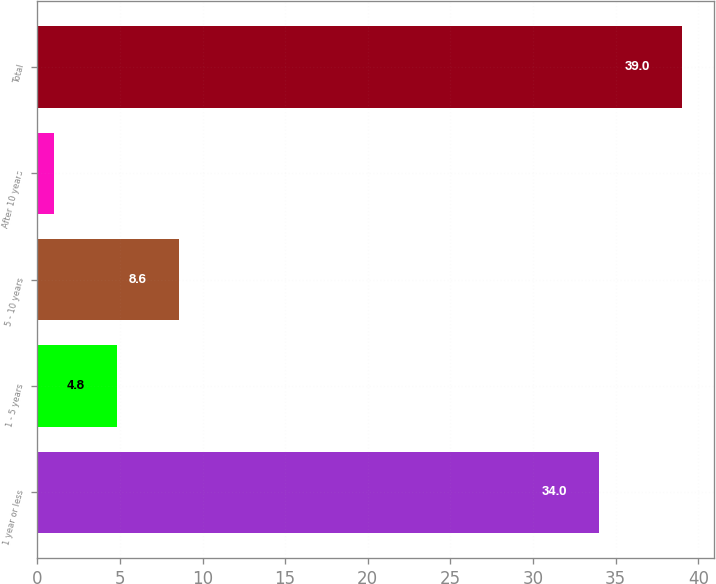Convert chart. <chart><loc_0><loc_0><loc_500><loc_500><bar_chart><fcel>1 year or less<fcel>1 - 5 years<fcel>5 - 10 years<fcel>After 10 years<fcel>Total<nl><fcel>34<fcel>4.8<fcel>8.6<fcel>1<fcel>39<nl></chart> 